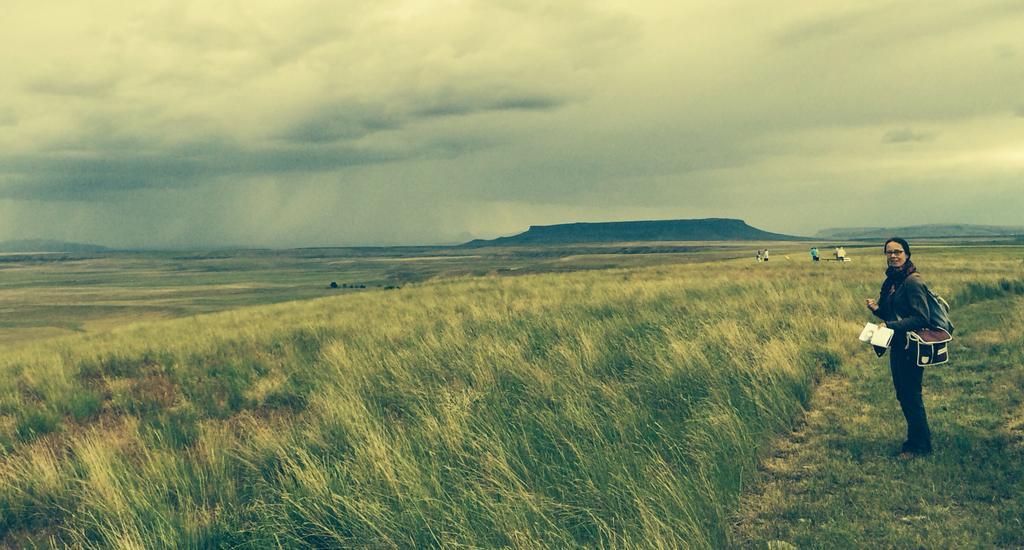Could you give a brief overview of what you see in this image? In this image I can see grass on the ground. On the right side there is a woman standing. In the background I can see a mountain and few people standing. At the top I can see clouds in the sky. 